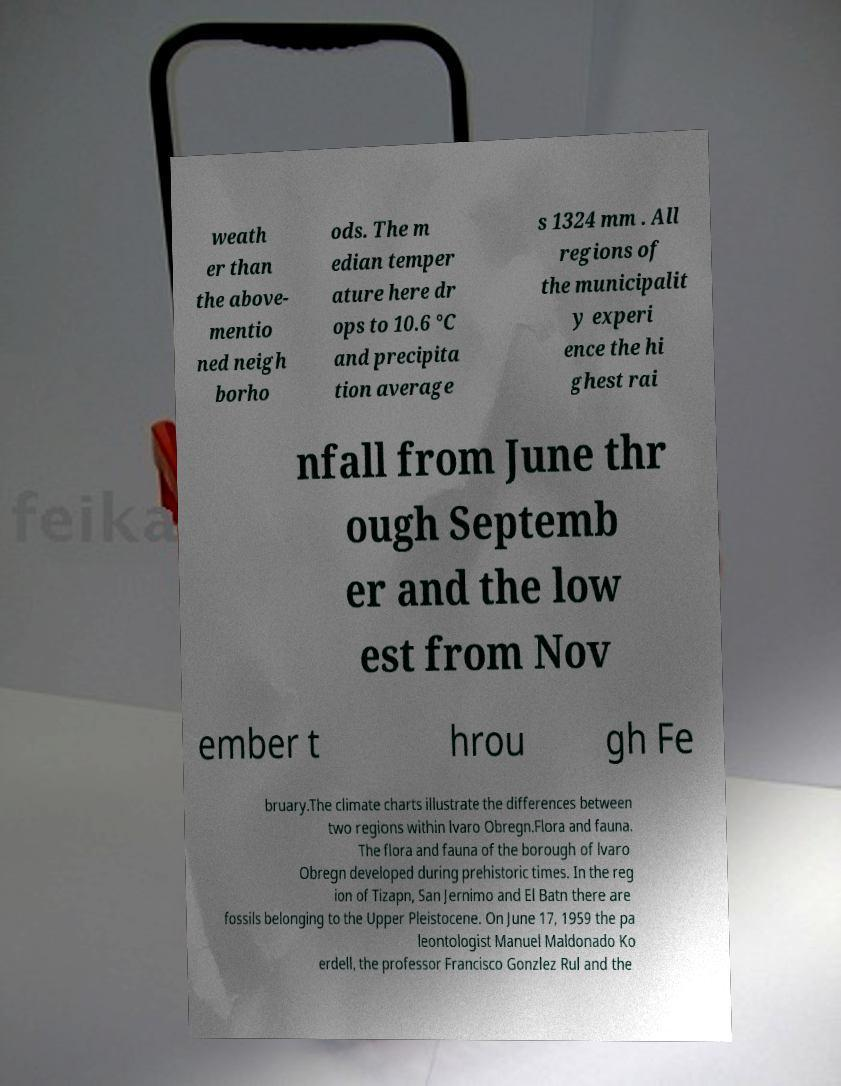Can you read and provide the text displayed in the image?This photo seems to have some interesting text. Can you extract and type it out for me? weath er than the above- mentio ned neigh borho ods. The m edian temper ature here dr ops to 10.6 °C and precipita tion average s 1324 mm . All regions of the municipalit y experi ence the hi ghest rai nfall from June thr ough Septemb er and the low est from Nov ember t hrou gh Fe bruary.The climate charts illustrate the differences between two regions within lvaro Obregn.Flora and fauna. The flora and fauna of the borough of lvaro Obregn developed during prehistoric times. In the reg ion of Tizapn, San Jernimo and El Batn there are fossils belonging to the Upper Pleistocene. On June 17, 1959 the pa leontologist Manuel Maldonado Ko erdell, the professor Francisco Gonzlez Rul and the 